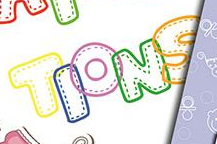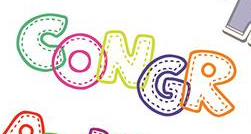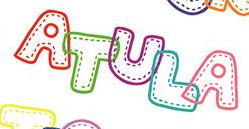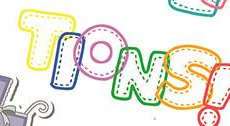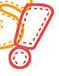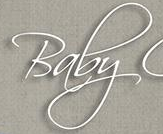What text appears in these images from left to right, separated by a semicolon? TIONS; CONGR; ATULA; TIONS; !; Baby 